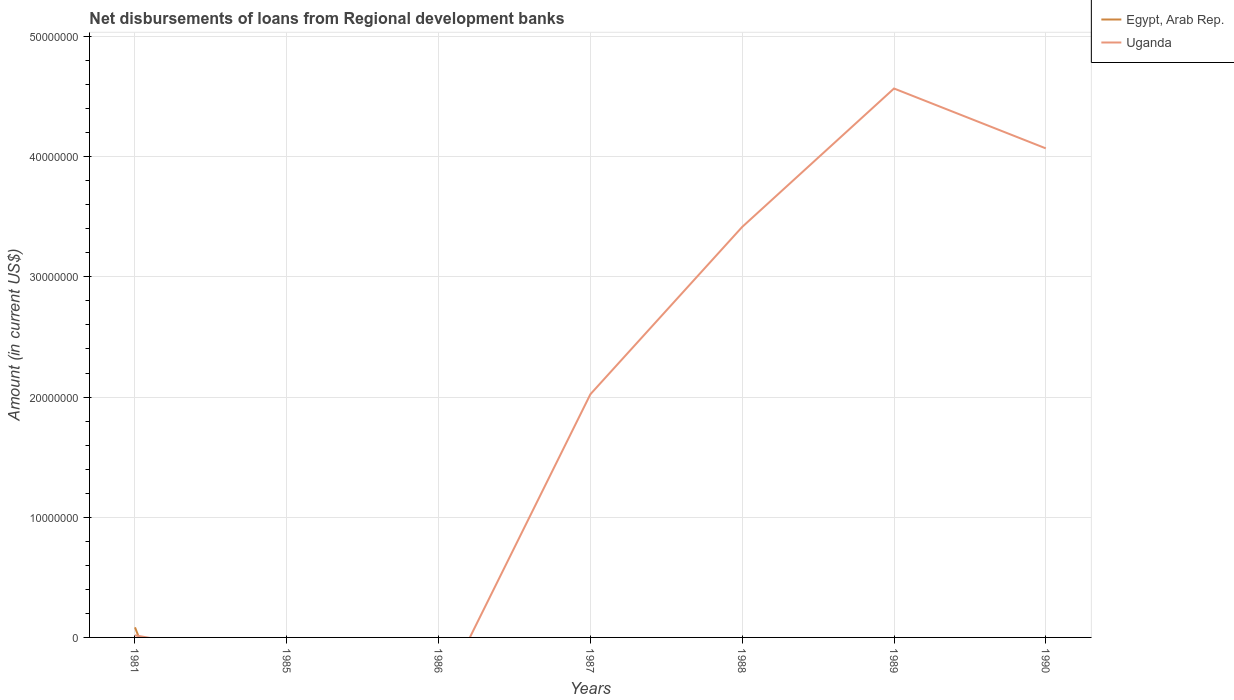Is the number of lines equal to the number of legend labels?
Make the answer very short. No. What is the total amount of disbursements of loans from regional development banks in Uganda in the graph?
Offer a very short reply. -2.05e+07. What is the difference between the highest and the second highest amount of disbursements of loans from regional development banks in Uganda?
Your answer should be very brief. 4.57e+07. What is the difference between the highest and the lowest amount of disbursements of loans from regional development banks in Egypt, Arab Rep.?
Provide a succinct answer. 1. Is the amount of disbursements of loans from regional development banks in Uganda strictly greater than the amount of disbursements of loans from regional development banks in Egypt, Arab Rep. over the years?
Offer a very short reply. No. Does the graph contain grids?
Your answer should be compact. Yes. How many legend labels are there?
Your answer should be very brief. 2. What is the title of the graph?
Your response must be concise. Net disbursements of loans from Regional development banks. Does "High income: OECD" appear as one of the legend labels in the graph?
Offer a very short reply. No. What is the Amount (in current US$) of Egypt, Arab Rep. in 1981?
Keep it short and to the point. 8.38e+05. What is the Amount (in current US$) in Uganda in 1981?
Offer a very short reply. 1.78e+05. What is the Amount (in current US$) of Egypt, Arab Rep. in 1985?
Make the answer very short. 0. What is the Amount (in current US$) of Uganda in 1985?
Make the answer very short. 0. What is the Amount (in current US$) in Egypt, Arab Rep. in 1986?
Your answer should be very brief. 0. What is the Amount (in current US$) in Uganda in 1987?
Your response must be concise. 2.02e+07. What is the Amount (in current US$) in Uganda in 1988?
Your answer should be compact. 3.42e+07. What is the Amount (in current US$) in Uganda in 1989?
Keep it short and to the point. 4.57e+07. What is the Amount (in current US$) in Egypt, Arab Rep. in 1990?
Provide a succinct answer. 0. What is the Amount (in current US$) in Uganda in 1990?
Offer a terse response. 4.07e+07. Across all years, what is the maximum Amount (in current US$) of Egypt, Arab Rep.?
Offer a terse response. 8.38e+05. Across all years, what is the maximum Amount (in current US$) in Uganda?
Your answer should be very brief. 4.57e+07. What is the total Amount (in current US$) in Egypt, Arab Rep. in the graph?
Offer a terse response. 8.38e+05. What is the total Amount (in current US$) of Uganda in the graph?
Give a very brief answer. 1.41e+08. What is the difference between the Amount (in current US$) in Uganda in 1981 and that in 1987?
Your answer should be compact. -2.01e+07. What is the difference between the Amount (in current US$) in Uganda in 1981 and that in 1988?
Give a very brief answer. -3.40e+07. What is the difference between the Amount (in current US$) of Uganda in 1981 and that in 1989?
Offer a terse response. -4.55e+07. What is the difference between the Amount (in current US$) in Uganda in 1981 and that in 1990?
Ensure brevity in your answer.  -4.05e+07. What is the difference between the Amount (in current US$) of Uganda in 1987 and that in 1988?
Your response must be concise. -1.39e+07. What is the difference between the Amount (in current US$) in Uganda in 1987 and that in 1989?
Your answer should be compact. -2.54e+07. What is the difference between the Amount (in current US$) of Uganda in 1987 and that in 1990?
Offer a very short reply. -2.05e+07. What is the difference between the Amount (in current US$) of Uganda in 1988 and that in 1989?
Your answer should be compact. -1.15e+07. What is the difference between the Amount (in current US$) of Uganda in 1988 and that in 1990?
Keep it short and to the point. -6.54e+06. What is the difference between the Amount (in current US$) in Uganda in 1989 and that in 1990?
Ensure brevity in your answer.  4.98e+06. What is the difference between the Amount (in current US$) of Egypt, Arab Rep. in 1981 and the Amount (in current US$) of Uganda in 1987?
Provide a succinct answer. -1.94e+07. What is the difference between the Amount (in current US$) in Egypt, Arab Rep. in 1981 and the Amount (in current US$) in Uganda in 1988?
Make the answer very short. -3.33e+07. What is the difference between the Amount (in current US$) of Egypt, Arab Rep. in 1981 and the Amount (in current US$) of Uganda in 1989?
Offer a terse response. -4.48e+07. What is the difference between the Amount (in current US$) in Egypt, Arab Rep. in 1981 and the Amount (in current US$) in Uganda in 1990?
Give a very brief answer. -3.99e+07. What is the average Amount (in current US$) in Egypt, Arab Rep. per year?
Your response must be concise. 1.20e+05. What is the average Amount (in current US$) of Uganda per year?
Keep it short and to the point. 2.01e+07. What is the ratio of the Amount (in current US$) in Uganda in 1981 to that in 1987?
Offer a terse response. 0.01. What is the ratio of the Amount (in current US$) in Uganda in 1981 to that in 1988?
Make the answer very short. 0.01. What is the ratio of the Amount (in current US$) in Uganda in 1981 to that in 1989?
Offer a terse response. 0. What is the ratio of the Amount (in current US$) of Uganda in 1981 to that in 1990?
Offer a terse response. 0. What is the ratio of the Amount (in current US$) in Uganda in 1987 to that in 1988?
Offer a very short reply. 0.59. What is the ratio of the Amount (in current US$) in Uganda in 1987 to that in 1989?
Provide a succinct answer. 0.44. What is the ratio of the Amount (in current US$) of Uganda in 1987 to that in 1990?
Offer a terse response. 0.5. What is the ratio of the Amount (in current US$) of Uganda in 1988 to that in 1989?
Make the answer very short. 0.75. What is the ratio of the Amount (in current US$) of Uganda in 1988 to that in 1990?
Offer a terse response. 0.84. What is the ratio of the Amount (in current US$) of Uganda in 1989 to that in 1990?
Ensure brevity in your answer.  1.12. What is the difference between the highest and the second highest Amount (in current US$) of Uganda?
Offer a terse response. 4.98e+06. What is the difference between the highest and the lowest Amount (in current US$) of Egypt, Arab Rep.?
Ensure brevity in your answer.  8.38e+05. What is the difference between the highest and the lowest Amount (in current US$) of Uganda?
Your answer should be compact. 4.57e+07. 